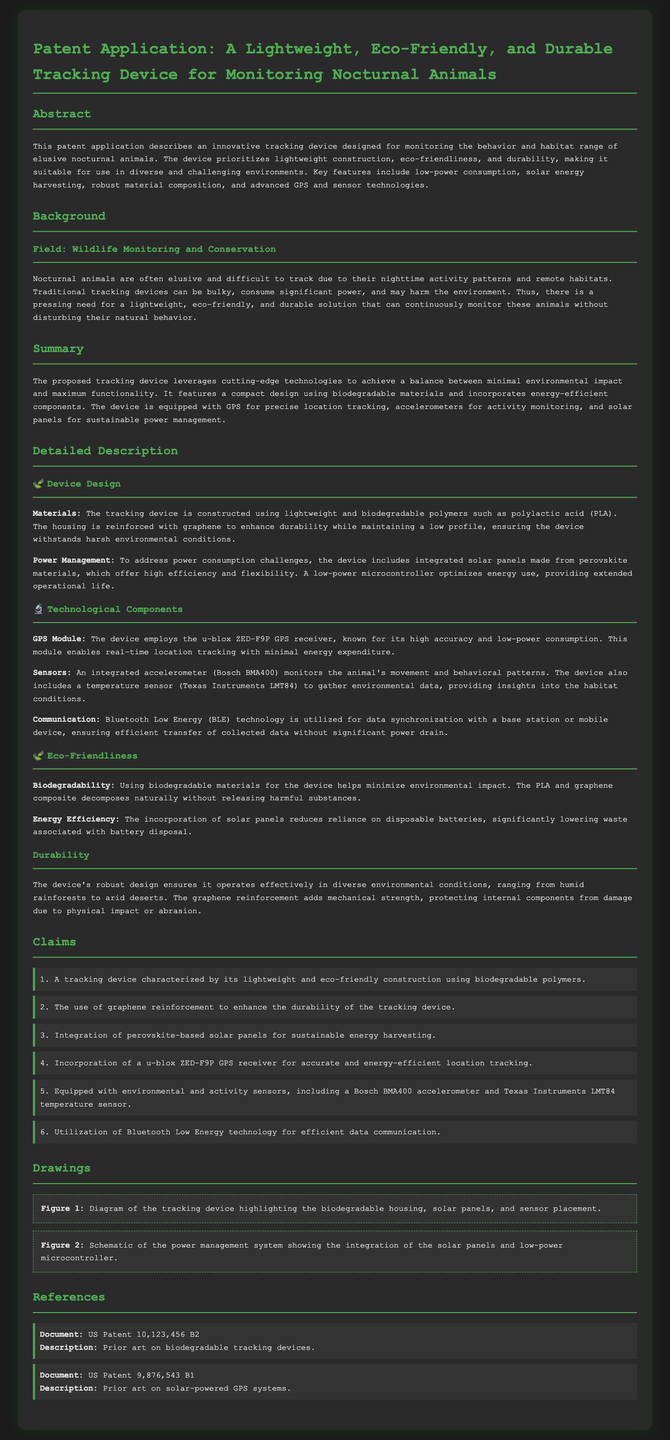What is the title of the patent application? The title is presented at the beginning of the document and describes the subject of the invention.
Answer: A Lightweight, Eco-Friendly, and Durable Tracking Device for Monitoring Nocturnal Animals What materials are used for the device's construction? The document specifies the materials mentioned under the Device Design section.
Answer: Biodegradable polymers such as polylactic acid (PLA) Which GPS receiver is used in the tracking device? The GPS module is detailed in the Technological Components section of the document.
Answer: u-blox ZED-F9P What unique feature does the device incorporate for sustainable energy? The Summary section highlights a crucial technological aspect of the device related to energy use.
Answer: Solar panels made from perovskite materials How many claims are stated in the patent application? The number of claims is mentioned in the Claims section, indicating the key assertions of the invention.
Answer: Six How does the device ensure minimal environmental impact? The Eco-Friendliness section elaborates on the device's design choices that contribute to this goal.
Answer: Using biodegradable materials What tech is used for data communication? The document specifies communication technology in the Technological Components section.
Answer: Bluetooth Low Energy (BLE) What is the purpose of the accelerometer in the device? The purpose is explained within the Technological Components part discussing integration of sensors.
Answer: Activity monitoring In which environmental conditions can the device operate effectively? The Durability section discusses the device's capability in various settings.
Answer: Diverse environmental conditions, ranging from humid rainforests to arid deserts 